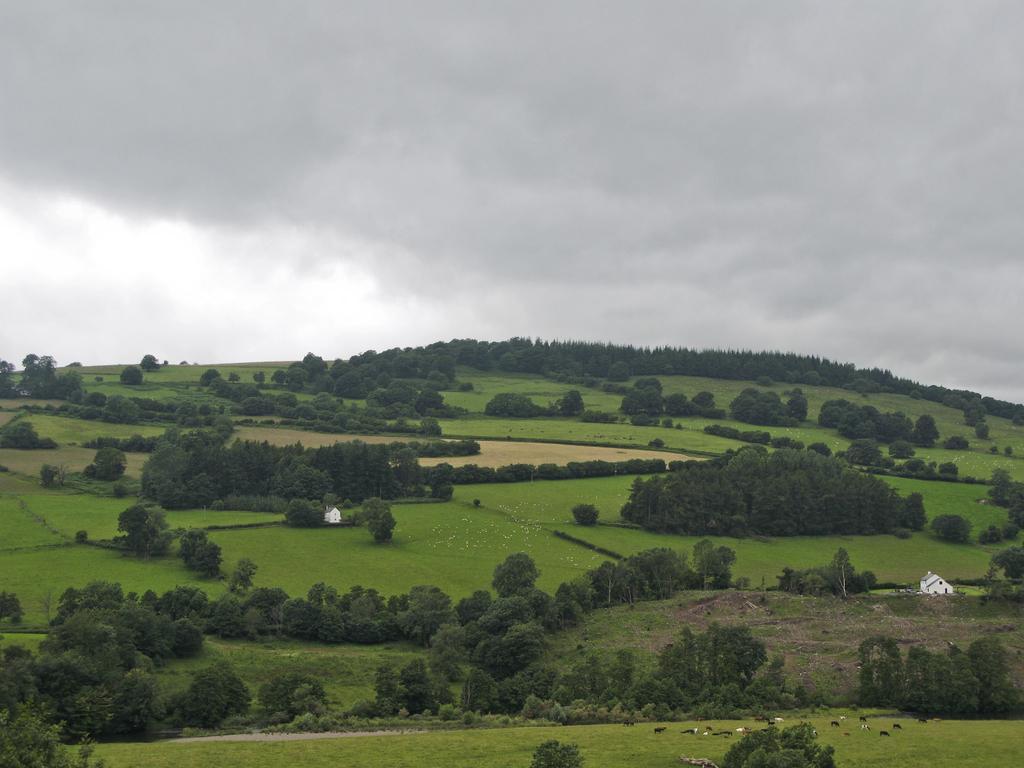Describe this image in one or two sentences. In this picture we can see the grass, trees, houses and in the background we can see the sky with clouds. 